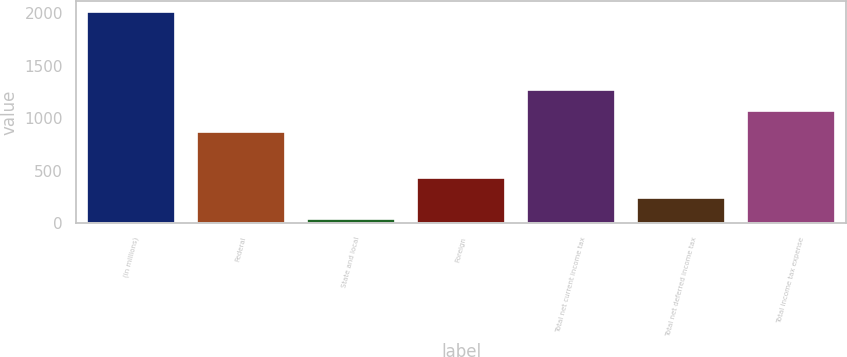Convert chart to OTSL. <chart><loc_0><loc_0><loc_500><loc_500><bar_chart><fcel>(in millions)<fcel>Federal<fcel>State and local<fcel>Foreign<fcel>Total net current income tax<fcel>Total net deferred income tax<fcel>Total income tax expense<nl><fcel>2013<fcel>869<fcel>39<fcel>433.8<fcel>1263.8<fcel>236.4<fcel>1066.4<nl></chart> 